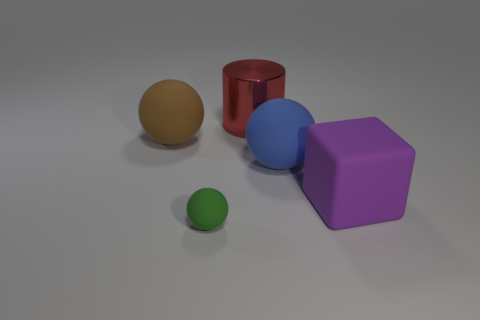Is there any other thing that has the same color as the big shiny cylinder?
Your answer should be compact. No. What number of rubber things are either purple things or small balls?
Keep it short and to the point. 2. There is a sphere in front of the rubber object that is on the right side of the big rubber sphere right of the small ball; what is its material?
Offer a terse response. Rubber. What is the material of the object that is behind the big ball that is left of the small rubber sphere?
Make the answer very short. Metal. Does the rubber object to the left of the tiny rubber object have the same size as the rubber sphere right of the big cylinder?
Make the answer very short. Yes. Is there any other thing that is made of the same material as the large blue object?
Your answer should be compact. Yes. What number of large things are green matte objects or purple matte things?
Give a very brief answer. 1. What number of objects are either big matte spheres right of the tiny green ball or green cubes?
Your answer should be compact. 1. Do the small rubber object and the matte block have the same color?
Provide a succinct answer. No. What number of other things are the same shape as the big purple object?
Provide a short and direct response. 0. 